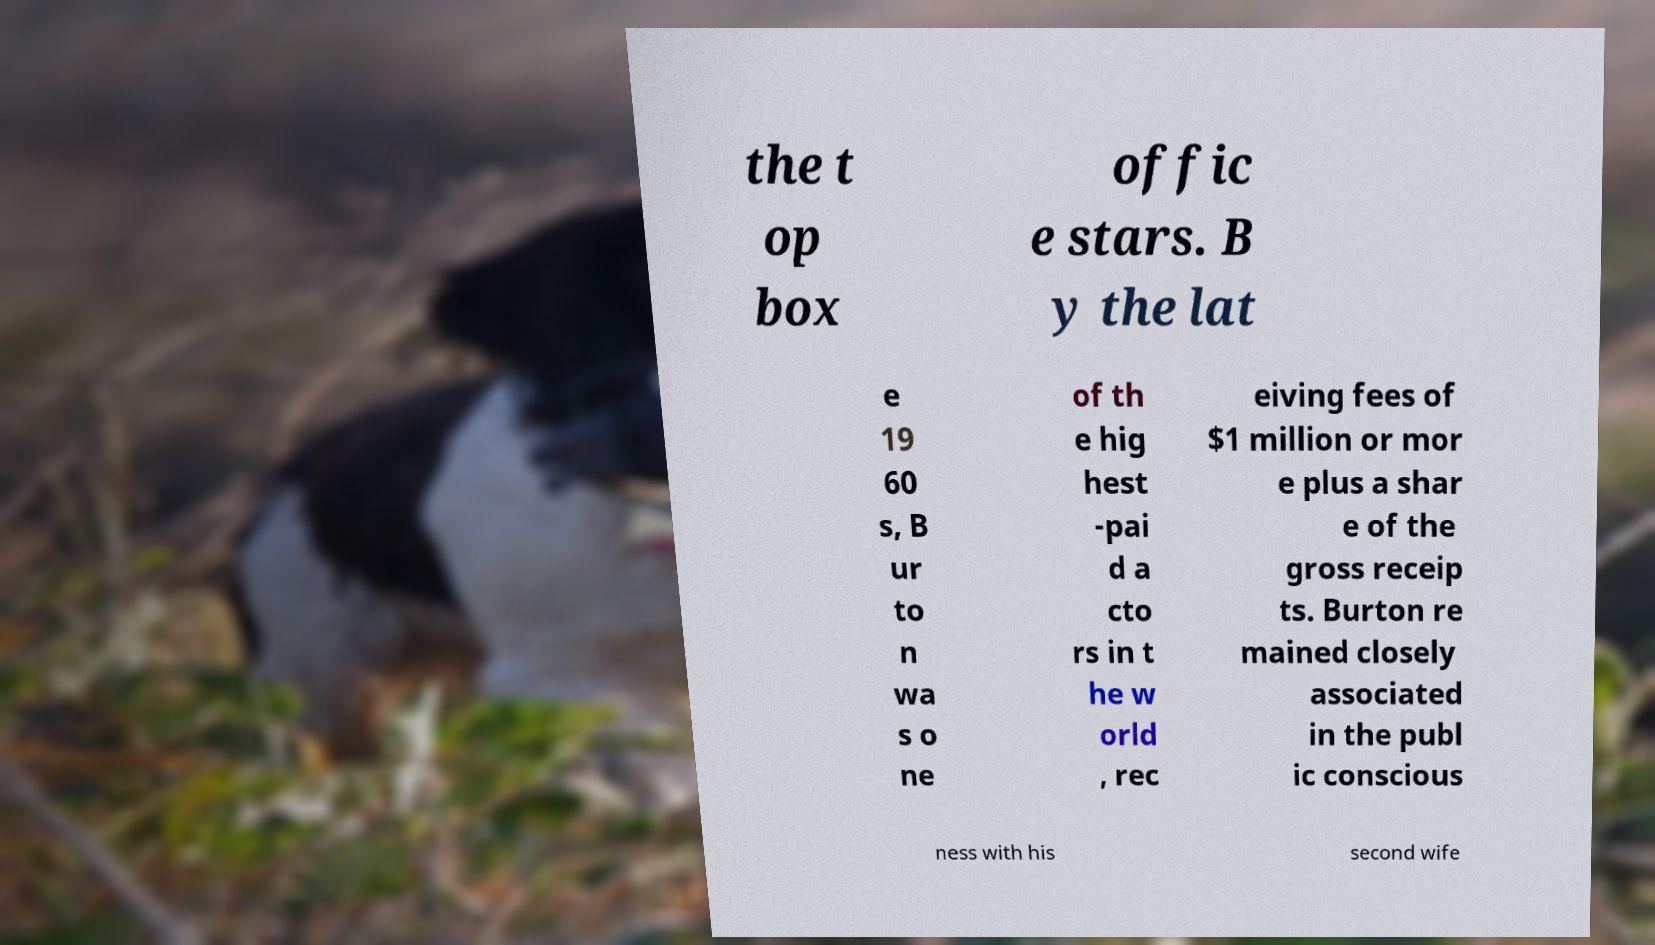Can you read and provide the text displayed in the image?This photo seems to have some interesting text. Can you extract and type it out for me? the t op box offic e stars. B y the lat e 19 60 s, B ur to n wa s o ne of th e hig hest -pai d a cto rs in t he w orld , rec eiving fees of $1 million or mor e plus a shar e of the gross receip ts. Burton re mained closely associated in the publ ic conscious ness with his second wife 